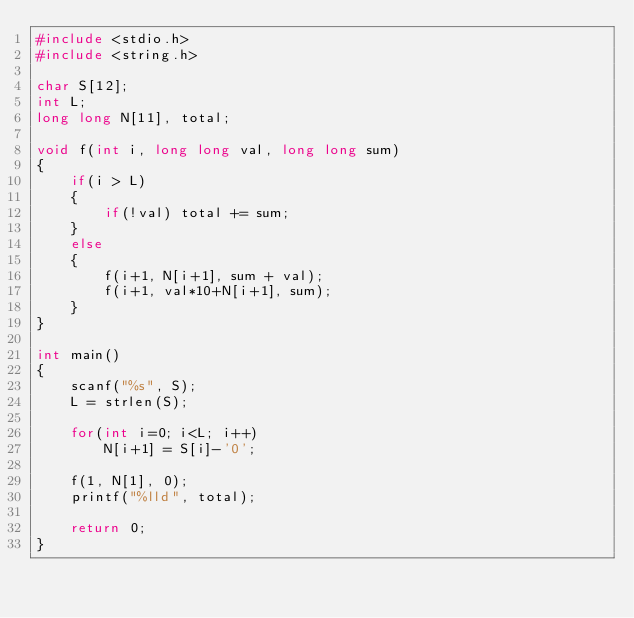<code> <loc_0><loc_0><loc_500><loc_500><_C++_>#include <stdio.h>
#include <string.h>

char S[12];
int L;
long long N[11], total;

void f(int i, long long val, long long sum)
{
	if(i > L)
	{
		if(!val) total += sum;
	}
	else
	{
		f(i+1, N[i+1], sum + val);
		f(i+1, val*10+N[i+1], sum);
	}
}

int main()
{
	scanf("%s", S);
	L = strlen(S);
	
	for(int i=0; i<L; i++)
		N[i+1] = S[i]-'0';
	
	f(1, N[1], 0);
	printf("%lld", total);
	
	return 0;
}</code> 